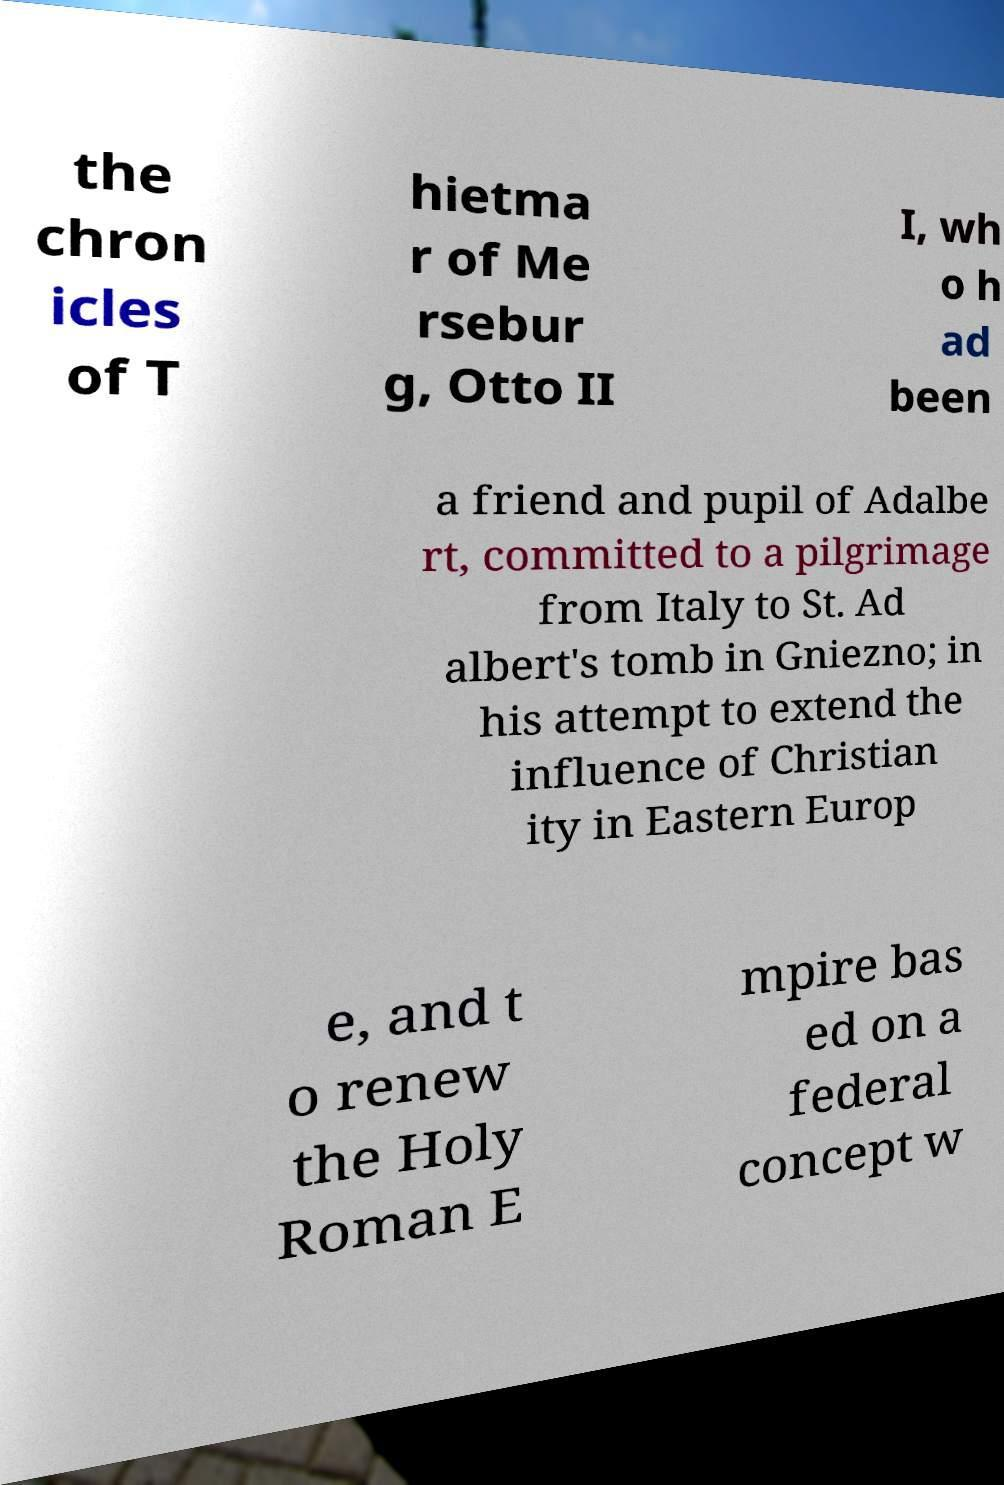Could you assist in decoding the text presented in this image and type it out clearly? the chron icles of T hietma r of Me rsebur g, Otto II I, wh o h ad been a friend and pupil of Adalbe rt, committed to a pilgrimage from Italy to St. Ad albert's tomb in Gniezno; in his attempt to extend the influence of Christian ity in Eastern Europ e, and t o renew the Holy Roman E mpire bas ed on a federal concept w 